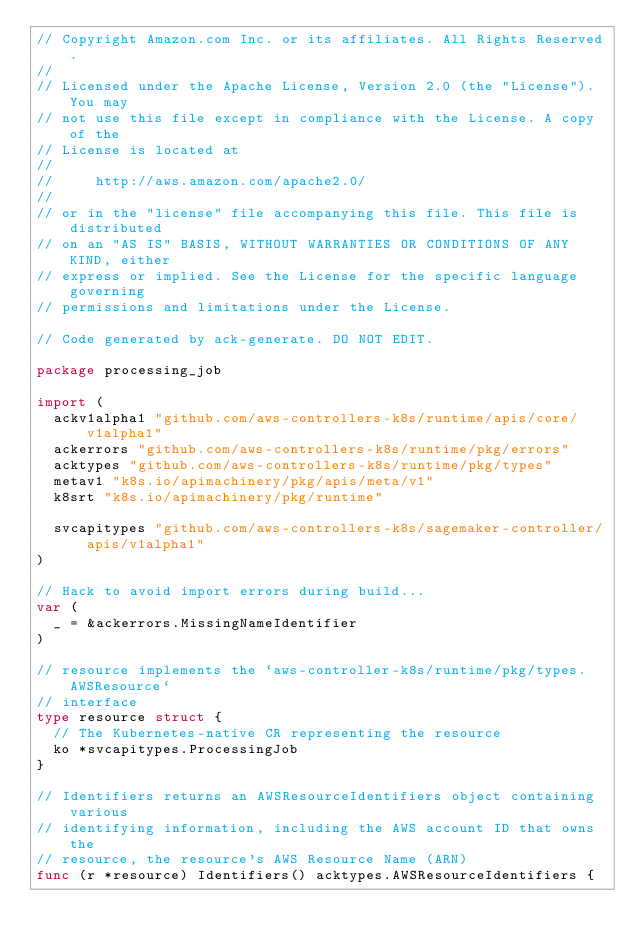<code> <loc_0><loc_0><loc_500><loc_500><_Go_>// Copyright Amazon.com Inc. or its affiliates. All Rights Reserved.
//
// Licensed under the Apache License, Version 2.0 (the "License"). You may
// not use this file except in compliance with the License. A copy of the
// License is located at
//
//     http://aws.amazon.com/apache2.0/
//
// or in the "license" file accompanying this file. This file is distributed
// on an "AS IS" BASIS, WITHOUT WARRANTIES OR CONDITIONS OF ANY KIND, either
// express or implied. See the License for the specific language governing
// permissions and limitations under the License.

// Code generated by ack-generate. DO NOT EDIT.

package processing_job

import (
	ackv1alpha1 "github.com/aws-controllers-k8s/runtime/apis/core/v1alpha1"
	ackerrors "github.com/aws-controllers-k8s/runtime/pkg/errors"
	acktypes "github.com/aws-controllers-k8s/runtime/pkg/types"
	metav1 "k8s.io/apimachinery/pkg/apis/meta/v1"
	k8srt "k8s.io/apimachinery/pkg/runtime"

	svcapitypes "github.com/aws-controllers-k8s/sagemaker-controller/apis/v1alpha1"
)

// Hack to avoid import errors during build...
var (
	_ = &ackerrors.MissingNameIdentifier
)

// resource implements the `aws-controller-k8s/runtime/pkg/types.AWSResource`
// interface
type resource struct {
	// The Kubernetes-native CR representing the resource
	ko *svcapitypes.ProcessingJob
}

// Identifiers returns an AWSResourceIdentifiers object containing various
// identifying information, including the AWS account ID that owns the
// resource, the resource's AWS Resource Name (ARN)
func (r *resource) Identifiers() acktypes.AWSResourceIdentifiers {</code> 